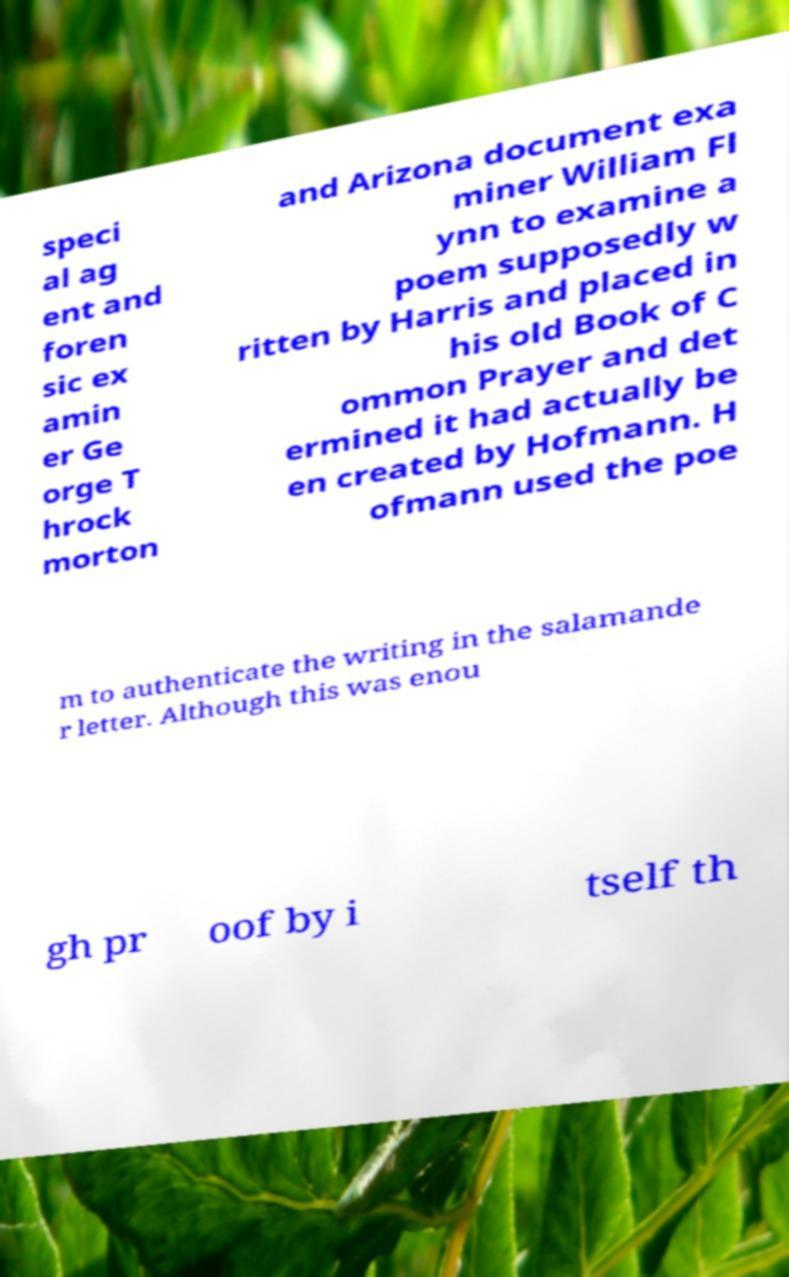For documentation purposes, I need the text within this image transcribed. Could you provide that? speci al ag ent and foren sic ex amin er Ge orge T hrock morton and Arizona document exa miner William Fl ynn to examine a poem supposedly w ritten by Harris and placed in his old Book of C ommon Prayer and det ermined it had actually be en created by Hofmann. H ofmann used the poe m to authenticate the writing in the salamande r letter. Although this was enou gh pr oof by i tself th 